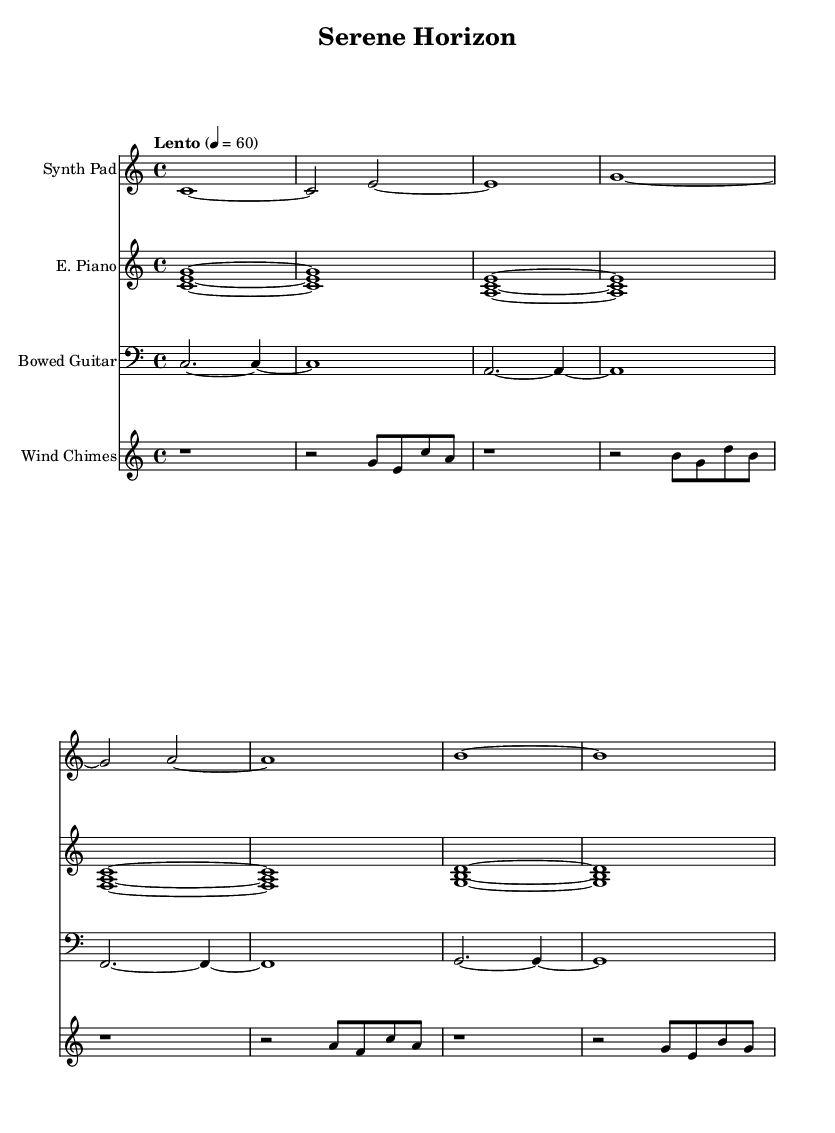What is the time signature of this music? The time signature is found at the beginning of the sheet music, indicated as 4/4. This means there are four beats per measure and the quarter note gets one beat.
Answer: 4/4 What is the tempo marking of this piece? The tempo marking is indicated at the beginning of the sheet music as "Lento" with a metronome marking of 60. This indicates a slow pace, specifically 60 beats per minute.
Answer: Lento, 60 How many different instruments are present in this score? By examining the score, we can see four distinct staves, each labeled for a different instrument: Synth Pad, E. Piano, Bowed Guitar, and Wind Chimes. This indicates that there are four different instruments.
Answer: 4 Which instrument has the lowest pitch range represented in the score? The Bowed Guitar staff is notated in the bass clef, which typically represents lower pitches compared to treble clefs used by Synth Pad, E. Piano, and Wind Chimes. Therefore, the Bowed Guitar has the lowest pitch range among the instruments.
Answer: Bowed Guitar What is the first chord played by the E. Piano? By looking at the E. Piano staff, the first chord is given as <c e g>, which represents a C major chord, played as a three-note harmony.
Answer: C major How is silence indicated in the Wind Chimes part? The Wind Chimes part shows rests indicated by 'r' at the beginning of the measure. This indicates silence for the duration of that measure, allowing for a space in the music.
Answer: rests 